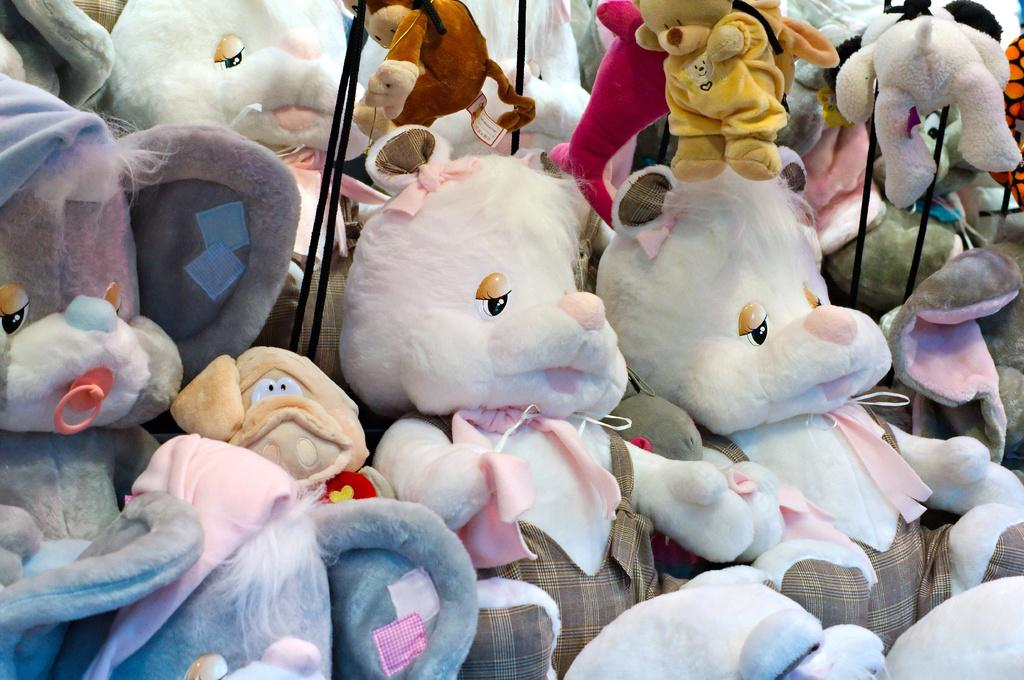What type of objects can be seen in the image? There are soft toys in the image. Can you describe the colors of the soft toys? The soft toys have various colors, including white, grey, cream, orange, pink, and yellow. Do the soft toys have any additional features? Yes, the soft toys have clothes on them. What other objects can be seen in the image? There are black color ropes in the image. Where is the calculator placed in the image? There is no calculator present in the image. What type of furniture is the cushion placed on in the image? There is no cushion present in the image. 